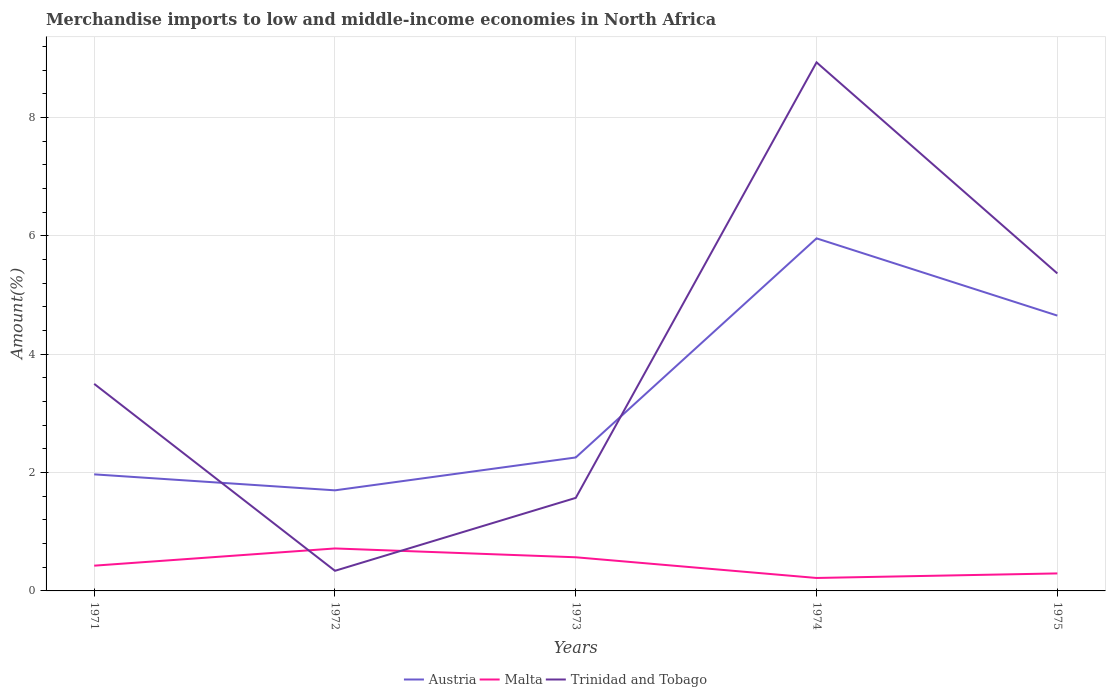How many different coloured lines are there?
Your answer should be compact. 3. Is the number of lines equal to the number of legend labels?
Provide a succinct answer. Yes. Across all years, what is the maximum percentage of amount earned from merchandise imports in Trinidad and Tobago?
Your answer should be compact. 0.34. In which year was the percentage of amount earned from merchandise imports in Malta maximum?
Provide a succinct answer. 1974. What is the total percentage of amount earned from merchandise imports in Austria in the graph?
Provide a succinct answer. 0.27. What is the difference between the highest and the second highest percentage of amount earned from merchandise imports in Malta?
Your answer should be very brief. 0.5. What is the difference between the highest and the lowest percentage of amount earned from merchandise imports in Trinidad and Tobago?
Your answer should be compact. 2. How many years are there in the graph?
Your answer should be compact. 5. What is the difference between two consecutive major ticks on the Y-axis?
Ensure brevity in your answer.  2. Are the values on the major ticks of Y-axis written in scientific E-notation?
Provide a short and direct response. No. Does the graph contain grids?
Provide a succinct answer. Yes. Where does the legend appear in the graph?
Give a very brief answer. Bottom center. What is the title of the graph?
Offer a very short reply. Merchandise imports to low and middle-income economies in North Africa. What is the label or title of the X-axis?
Your response must be concise. Years. What is the label or title of the Y-axis?
Keep it short and to the point. Amount(%). What is the Amount(%) in Austria in 1971?
Keep it short and to the point. 1.97. What is the Amount(%) in Malta in 1971?
Offer a very short reply. 0.43. What is the Amount(%) in Trinidad and Tobago in 1971?
Provide a short and direct response. 3.5. What is the Amount(%) of Austria in 1972?
Offer a terse response. 1.7. What is the Amount(%) in Malta in 1972?
Provide a short and direct response. 0.72. What is the Amount(%) of Trinidad and Tobago in 1972?
Make the answer very short. 0.34. What is the Amount(%) of Austria in 1973?
Your response must be concise. 2.26. What is the Amount(%) in Malta in 1973?
Make the answer very short. 0.57. What is the Amount(%) in Trinidad and Tobago in 1973?
Provide a short and direct response. 1.57. What is the Amount(%) of Austria in 1974?
Ensure brevity in your answer.  5.96. What is the Amount(%) of Malta in 1974?
Keep it short and to the point. 0.22. What is the Amount(%) in Trinidad and Tobago in 1974?
Keep it short and to the point. 8.93. What is the Amount(%) of Austria in 1975?
Offer a very short reply. 4.65. What is the Amount(%) in Malta in 1975?
Provide a succinct answer. 0.3. What is the Amount(%) of Trinidad and Tobago in 1975?
Provide a short and direct response. 5.37. Across all years, what is the maximum Amount(%) of Austria?
Provide a short and direct response. 5.96. Across all years, what is the maximum Amount(%) in Malta?
Offer a very short reply. 0.72. Across all years, what is the maximum Amount(%) in Trinidad and Tobago?
Provide a succinct answer. 8.93. Across all years, what is the minimum Amount(%) of Austria?
Your answer should be compact. 1.7. Across all years, what is the minimum Amount(%) of Malta?
Offer a terse response. 0.22. Across all years, what is the minimum Amount(%) of Trinidad and Tobago?
Your response must be concise. 0.34. What is the total Amount(%) of Austria in the graph?
Provide a succinct answer. 16.54. What is the total Amount(%) of Malta in the graph?
Give a very brief answer. 2.23. What is the total Amount(%) of Trinidad and Tobago in the graph?
Provide a succinct answer. 19.71. What is the difference between the Amount(%) of Austria in 1971 and that in 1972?
Provide a succinct answer. 0.27. What is the difference between the Amount(%) of Malta in 1971 and that in 1972?
Ensure brevity in your answer.  -0.29. What is the difference between the Amount(%) of Trinidad and Tobago in 1971 and that in 1972?
Provide a succinct answer. 3.16. What is the difference between the Amount(%) of Austria in 1971 and that in 1973?
Offer a terse response. -0.29. What is the difference between the Amount(%) of Malta in 1971 and that in 1973?
Your answer should be very brief. -0.14. What is the difference between the Amount(%) of Trinidad and Tobago in 1971 and that in 1973?
Keep it short and to the point. 1.93. What is the difference between the Amount(%) of Austria in 1971 and that in 1974?
Your answer should be compact. -3.99. What is the difference between the Amount(%) of Malta in 1971 and that in 1974?
Keep it short and to the point. 0.21. What is the difference between the Amount(%) of Trinidad and Tobago in 1971 and that in 1974?
Provide a short and direct response. -5.43. What is the difference between the Amount(%) in Austria in 1971 and that in 1975?
Provide a succinct answer. -2.68. What is the difference between the Amount(%) of Malta in 1971 and that in 1975?
Give a very brief answer. 0.13. What is the difference between the Amount(%) in Trinidad and Tobago in 1971 and that in 1975?
Give a very brief answer. -1.87. What is the difference between the Amount(%) of Austria in 1972 and that in 1973?
Your answer should be compact. -0.56. What is the difference between the Amount(%) of Malta in 1972 and that in 1973?
Provide a succinct answer. 0.15. What is the difference between the Amount(%) of Trinidad and Tobago in 1972 and that in 1973?
Offer a very short reply. -1.23. What is the difference between the Amount(%) of Austria in 1972 and that in 1974?
Ensure brevity in your answer.  -4.26. What is the difference between the Amount(%) of Malta in 1972 and that in 1974?
Ensure brevity in your answer.  0.5. What is the difference between the Amount(%) in Trinidad and Tobago in 1972 and that in 1974?
Your response must be concise. -8.59. What is the difference between the Amount(%) of Austria in 1972 and that in 1975?
Provide a succinct answer. -2.95. What is the difference between the Amount(%) of Malta in 1972 and that in 1975?
Provide a succinct answer. 0.42. What is the difference between the Amount(%) in Trinidad and Tobago in 1972 and that in 1975?
Offer a terse response. -5.03. What is the difference between the Amount(%) in Austria in 1973 and that in 1974?
Make the answer very short. -3.7. What is the difference between the Amount(%) of Malta in 1973 and that in 1974?
Your answer should be compact. 0.35. What is the difference between the Amount(%) of Trinidad and Tobago in 1973 and that in 1974?
Make the answer very short. -7.36. What is the difference between the Amount(%) of Austria in 1973 and that in 1975?
Keep it short and to the point. -2.4. What is the difference between the Amount(%) of Malta in 1973 and that in 1975?
Offer a terse response. 0.27. What is the difference between the Amount(%) of Trinidad and Tobago in 1973 and that in 1975?
Ensure brevity in your answer.  -3.79. What is the difference between the Amount(%) in Austria in 1974 and that in 1975?
Make the answer very short. 1.31. What is the difference between the Amount(%) in Malta in 1974 and that in 1975?
Make the answer very short. -0.08. What is the difference between the Amount(%) of Trinidad and Tobago in 1974 and that in 1975?
Provide a succinct answer. 3.57. What is the difference between the Amount(%) of Austria in 1971 and the Amount(%) of Malta in 1972?
Give a very brief answer. 1.25. What is the difference between the Amount(%) in Austria in 1971 and the Amount(%) in Trinidad and Tobago in 1972?
Offer a terse response. 1.63. What is the difference between the Amount(%) of Malta in 1971 and the Amount(%) of Trinidad and Tobago in 1972?
Provide a succinct answer. 0.09. What is the difference between the Amount(%) of Austria in 1971 and the Amount(%) of Malta in 1973?
Provide a short and direct response. 1.4. What is the difference between the Amount(%) of Austria in 1971 and the Amount(%) of Trinidad and Tobago in 1973?
Your answer should be compact. 0.4. What is the difference between the Amount(%) in Malta in 1971 and the Amount(%) in Trinidad and Tobago in 1973?
Provide a short and direct response. -1.15. What is the difference between the Amount(%) of Austria in 1971 and the Amount(%) of Malta in 1974?
Your answer should be very brief. 1.75. What is the difference between the Amount(%) in Austria in 1971 and the Amount(%) in Trinidad and Tobago in 1974?
Your answer should be very brief. -6.96. What is the difference between the Amount(%) of Malta in 1971 and the Amount(%) of Trinidad and Tobago in 1974?
Your answer should be very brief. -8.51. What is the difference between the Amount(%) of Austria in 1971 and the Amount(%) of Malta in 1975?
Ensure brevity in your answer.  1.67. What is the difference between the Amount(%) of Austria in 1971 and the Amount(%) of Trinidad and Tobago in 1975?
Ensure brevity in your answer.  -3.4. What is the difference between the Amount(%) in Malta in 1971 and the Amount(%) in Trinidad and Tobago in 1975?
Make the answer very short. -4.94. What is the difference between the Amount(%) of Austria in 1972 and the Amount(%) of Malta in 1973?
Give a very brief answer. 1.13. What is the difference between the Amount(%) of Austria in 1972 and the Amount(%) of Trinidad and Tobago in 1973?
Offer a terse response. 0.13. What is the difference between the Amount(%) of Malta in 1972 and the Amount(%) of Trinidad and Tobago in 1973?
Ensure brevity in your answer.  -0.85. What is the difference between the Amount(%) in Austria in 1972 and the Amount(%) in Malta in 1974?
Your answer should be very brief. 1.48. What is the difference between the Amount(%) in Austria in 1972 and the Amount(%) in Trinidad and Tobago in 1974?
Provide a succinct answer. -7.23. What is the difference between the Amount(%) of Malta in 1972 and the Amount(%) of Trinidad and Tobago in 1974?
Provide a short and direct response. -8.22. What is the difference between the Amount(%) of Austria in 1972 and the Amount(%) of Malta in 1975?
Offer a very short reply. 1.4. What is the difference between the Amount(%) of Austria in 1972 and the Amount(%) of Trinidad and Tobago in 1975?
Provide a short and direct response. -3.67. What is the difference between the Amount(%) of Malta in 1972 and the Amount(%) of Trinidad and Tobago in 1975?
Offer a very short reply. -4.65. What is the difference between the Amount(%) in Austria in 1973 and the Amount(%) in Malta in 1974?
Provide a succinct answer. 2.04. What is the difference between the Amount(%) of Austria in 1973 and the Amount(%) of Trinidad and Tobago in 1974?
Your answer should be compact. -6.68. What is the difference between the Amount(%) of Malta in 1973 and the Amount(%) of Trinidad and Tobago in 1974?
Keep it short and to the point. -8.37. What is the difference between the Amount(%) of Austria in 1973 and the Amount(%) of Malta in 1975?
Ensure brevity in your answer.  1.96. What is the difference between the Amount(%) of Austria in 1973 and the Amount(%) of Trinidad and Tobago in 1975?
Ensure brevity in your answer.  -3.11. What is the difference between the Amount(%) in Malta in 1973 and the Amount(%) in Trinidad and Tobago in 1975?
Offer a very short reply. -4.8. What is the difference between the Amount(%) of Austria in 1974 and the Amount(%) of Malta in 1975?
Ensure brevity in your answer.  5.66. What is the difference between the Amount(%) in Austria in 1974 and the Amount(%) in Trinidad and Tobago in 1975?
Offer a very short reply. 0.59. What is the difference between the Amount(%) in Malta in 1974 and the Amount(%) in Trinidad and Tobago in 1975?
Your answer should be compact. -5.15. What is the average Amount(%) of Austria per year?
Provide a succinct answer. 3.31. What is the average Amount(%) of Malta per year?
Ensure brevity in your answer.  0.45. What is the average Amount(%) in Trinidad and Tobago per year?
Your response must be concise. 3.94. In the year 1971, what is the difference between the Amount(%) of Austria and Amount(%) of Malta?
Make the answer very short. 1.54. In the year 1971, what is the difference between the Amount(%) in Austria and Amount(%) in Trinidad and Tobago?
Offer a terse response. -1.53. In the year 1971, what is the difference between the Amount(%) of Malta and Amount(%) of Trinidad and Tobago?
Offer a terse response. -3.07. In the year 1972, what is the difference between the Amount(%) in Austria and Amount(%) in Malta?
Your answer should be very brief. 0.98. In the year 1972, what is the difference between the Amount(%) of Austria and Amount(%) of Trinidad and Tobago?
Make the answer very short. 1.36. In the year 1972, what is the difference between the Amount(%) of Malta and Amount(%) of Trinidad and Tobago?
Make the answer very short. 0.38. In the year 1973, what is the difference between the Amount(%) of Austria and Amount(%) of Malta?
Make the answer very short. 1.69. In the year 1973, what is the difference between the Amount(%) of Austria and Amount(%) of Trinidad and Tobago?
Your answer should be very brief. 0.68. In the year 1973, what is the difference between the Amount(%) of Malta and Amount(%) of Trinidad and Tobago?
Offer a terse response. -1. In the year 1974, what is the difference between the Amount(%) of Austria and Amount(%) of Malta?
Your answer should be compact. 5.74. In the year 1974, what is the difference between the Amount(%) of Austria and Amount(%) of Trinidad and Tobago?
Provide a short and direct response. -2.98. In the year 1974, what is the difference between the Amount(%) in Malta and Amount(%) in Trinidad and Tobago?
Offer a terse response. -8.72. In the year 1975, what is the difference between the Amount(%) of Austria and Amount(%) of Malta?
Give a very brief answer. 4.36. In the year 1975, what is the difference between the Amount(%) of Austria and Amount(%) of Trinidad and Tobago?
Provide a short and direct response. -0.71. In the year 1975, what is the difference between the Amount(%) of Malta and Amount(%) of Trinidad and Tobago?
Your answer should be compact. -5.07. What is the ratio of the Amount(%) in Austria in 1971 to that in 1972?
Your answer should be compact. 1.16. What is the ratio of the Amount(%) in Malta in 1971 to that in 1972?
Keep it short and to the point. 0.59. What is the ratio of the Amount(%) of Trinidad and Tobago in 1971 to that in 1972?
Ensure brevity in your answer.  10.29. What is the ratio of the Amount(%) in Austria in 1971 to that in 1973?
Provide a short and direct response. 0.87. What is the ratio of the Amount(%) of Malta in 1971 to that in 1973?
Offer a very short reply. 0.75. What is the ratio of the Amount(%) of Trinidad and Tobago in 1971 to that in 1973?
Ensure brevity in your answer.  2.23. What is the ratio of the Amount(%) in Austria in 1971 to that in 1974?
Offer a very short reply. 0.33. What is the ratio of the Amount(%) in Malta in 1971 to that in 1974?
Give a very brief answer. 1.95. What is the ratio of the Amount(%) in Trinidad and Tobago in 1971 to that in 1974?
Keep it short and to the point. 0.39. What is the ratio of the Amount(%) of Austria in 1971 to that in 1975?
Make the answer very short. 0.42. What is the ratio of the Amount(%) of Malta in 1971 to that in 1975?
Your response must be concise. 1.44. What is the ratio of the Amount(%) of Trinidad and Tobago in 1971 to that in 1975?
Provide a short and direct response. 0.65. What is the ratio of the Amount(%) of Austria in 1972 to that in 1973?
Provide a short and direct response. 0.75. What is the ratio of the Amount(%) in Malta in 1972 to that in 1973?
Ensure brevity in your answer.  1.26. What is the ratio of the Amount(%) in Trinidad and Tobago in 1972 to that in 1973?
Make the answer very short. 0.22. What is the ratio of the Amount(%) in Austria in 1972 to that in 1974?
Offer a very short reply. 0.29. What is the ratio of the Amount(%) in Malta in 1972 to that in 1974?
Provide a succinct answer. 3.28. What is the ratio of the Amount(%) in Trinidad and Tobago in 1972 to that in 1974?
Ensure brevity in your answer.  0.04. What is the ratio of the Amount(%) in Austria in 1972 to that in 1975?
Your response must be concise. 0.37. What is the ratio of the Amount(%) in Malta in 1972 to that in 1975?
Make the answer very short. 2.43. What is the ratio of the Amount(%) of Trinidad and Tobago in 1972 to that in 1975?
Provide a succinct answer. 0.06. What is the ratio of the Amount(%) of Austria in 1973 to that in 1974?
Ensure brevity in your answer.  0.38. What is the ratio of the Amount(%) of Malta in 1973 to that in 1974?
Ensure brevity in your answer.  2.6. What is the ratio of the Amount(%) of Trinidad and Tobago in 1973 to that in 1974?
Your answer should be very brief. 0.18. What is the ratio of the Amount(%) in Austria in 1973 to that in 1975?
Make the answer very short. 0.48. What is the ratio of the Amount(%) of Malta in 1973 to that in 1975?
Your response must be concise. 1.92. What is the ratio of the Amount(%) of Trinidad and Tobago in 1973 to that in 1975?
Give a very brief answer. 0.29. What is the ratio of the Amount(%) of Austria in 1974 to that in 1975?
Your answer should be very brief. 1.28. What is the ratio of the Amount(%) in Malta in 1974 to that in 1975?
Keep it short and to the point. 0.74. What is the ratio of the Amount(%) in Trinidad and Tobago in 1974 to that in 1975?
Make the answer very short. 1.66. What is the difference between the highest and the second highest Amount(%) in Austria?
Your answer should be very brief. 1.31. What is the difference between the highest and the second highest Amount(%) of Malta?
Provide a succinct answer. 0.15. What is the difference between the highest and the second highest Amount(%) of Trinidad and Tobago?
Ensure brevity in your answer.  3.57. What is the difference between the highest and the lowest Amount(%) in Austria?
Your answer should be very brief. 4.26. What is the difference between the highest and the lowest Amount(%) in Malta?
Your response must be concise. 0.5. What is the difference between the highest and the lowest Amount(%) of Trinidad and Tobago?
Your response must be concise. 8.59. 